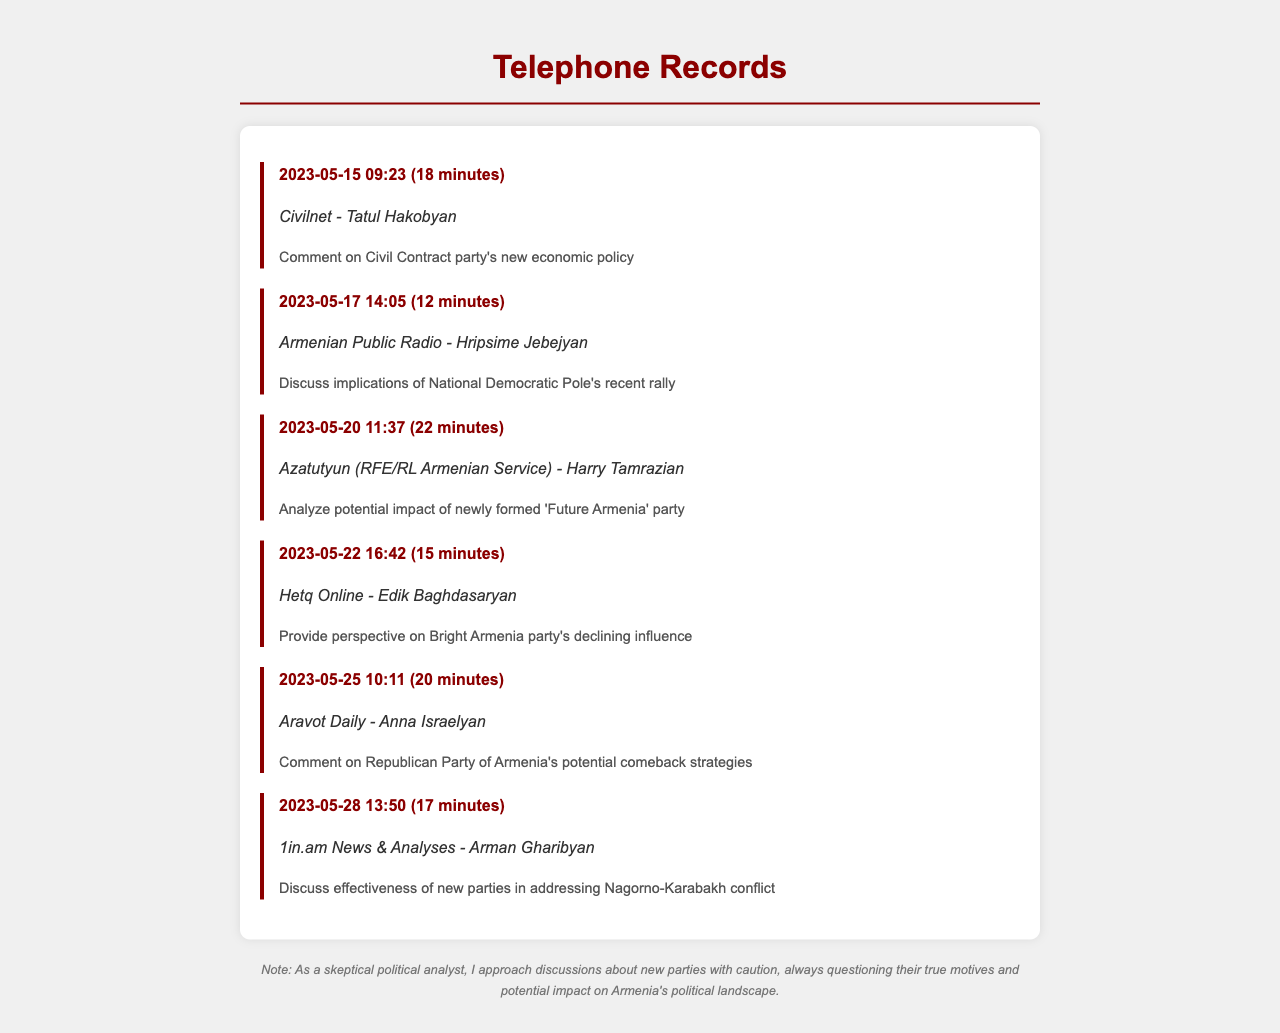what is the date of the call to Civilnet? The date of the call to Civilnet is recorded in the document as 2023-05-15.
Answer: 2023-05-15 who was the journalist contacted regarding Future Armenia party? The document lists Harry Tamrazian as the journalist contacted to analyze the Future Armenia party.
Answer: Harry Tamrazian how long was the call with Hripsime Jebejyan? The call duration is specified in the entry for Hripsime Jebejyan, which is 12 minutes.
Answer: 12 minutes what is the purpose of the call on May 28? The purpose of the call on May 28 is to discuss the effectiveness of new parties in addressing the Nagorno-Karabakh conflict.
Answer: Discuss effectiveness of new parties in addressing Nagorno-Karabakh conflict which media outlet did the analyst contact for commentary on Bright Armenia party? The entry mentions Hetq Online as the media outlet for commentary on Bright Armenia party.
Answer: Hetq Online which party's economic policy was discussed on May 15? The analyst commented on the Civil Contract party's new economic policy during the call on May 15.
Answer: Civil Contract party how many minutes was the conversation regarding Republican Party of Armenia? The document states that the conversation regarding the Republican Party of Armenia lasted 20 minutes.
Answer: 20 minutes what is the common theme in the calls on May 20 and May 22? Both calls relate to the situation and influence of specific Armenian political parties and their recent actions.
Answer: Political parties' influence who was the analyst’s contact for discussing the National Democratic Pole's rally? The document indicates that the contact for discussing the rally was Hripsime Jebejyan from Armenian Public Radio.
Answer: Hripsime Jebejyan 